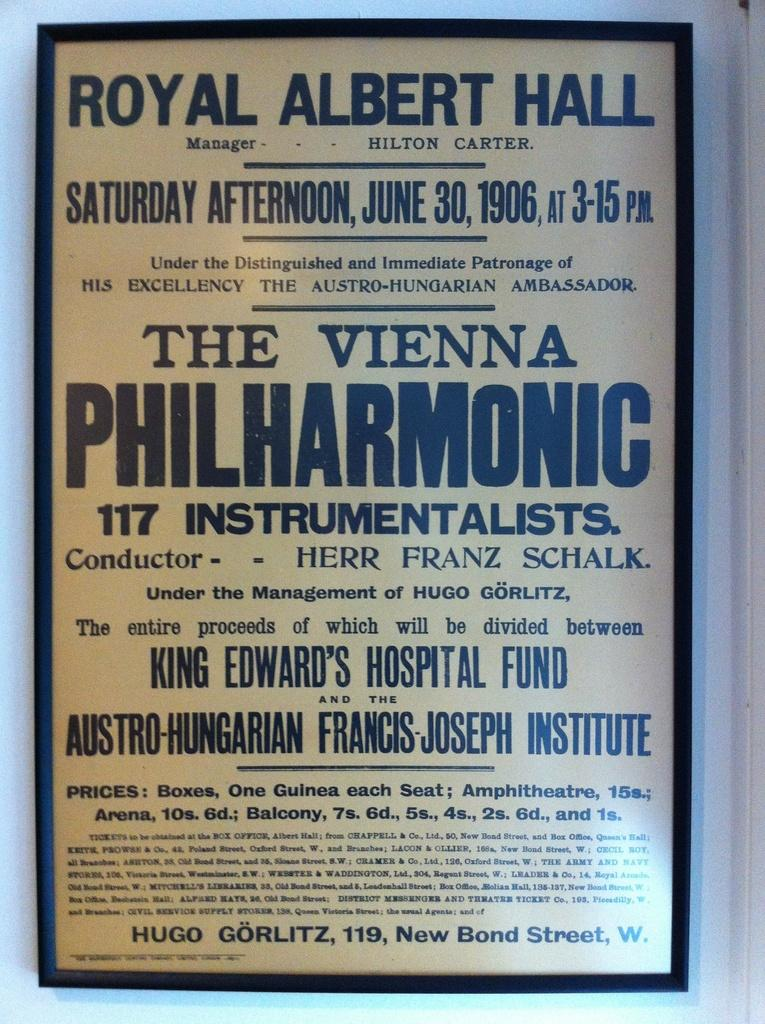<image>
Offer a succinct explanation of the picture presented. An ad for an event on Saturday afternoon is displayed. 